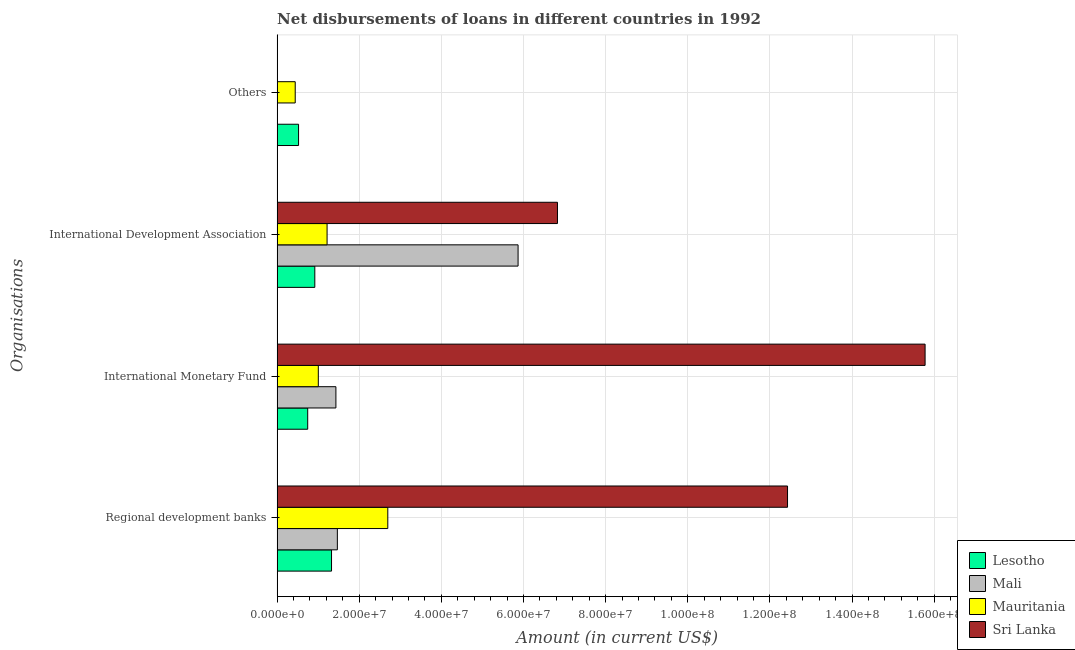How many different coloured bars are there?
Ensure brevity in your answer.  4. How many groups of bars are there?
Offer a very short reply. 4. Are the number of bars per tick equal to the number of legend labels?
Offer a very short reply. No. Are the number of bars on each tick of the Y-axis equal?
Give a very brief answer. No. How many bars are there on the 4th tick from the bottom?
Your answer should be very brief. 2. What is the label of the 3rd group of bars from the top?
Offer a very short reply. International Monetary Fund. What is the amount of loan disimbursed by regional development banks in Sri Lanka?
Ensure brevity in your answer.  1.24e+08. Across all countries, what is the maximum amount of loan disimbursed by international development association?
Your answer should be compact. 6.83e+07. Across all countries, what is the minimum amount of loan disimbursed by regional development banks?
Your answer should be compact. 1.32e+07. In which country was the amount of loan disimbursed by other organisations maximum?
Make the answer very short. Lesotho. What is the total amount of loan disimbursed by international development association in the graph?
Your response must be concise. 1.48e+08. What is the difference between the amount of loan disimbursed by international development association in Sri Lanka and that in Mali?
Offer a very short reply. 9.59e+06. What is the difference between the amount of loan disimbursed by international monetary fund in Mauritania and the amount of loan disimbursed by regional development banks in Sri Lanka?
Provide a short and direct response. -1.14e+08. What is the average amount of loan disimbursed by regional development banks per country?
Keep it short and to the point. 4.48e+07. What is the difference between the amount of loan disimbursed by international monetary fund and amount of loan disimbursed by international development association in Mali?
Keep it short and to the point. -4.44e+07. In how many countries, is the amount of loan disimbursed by other organisations greater than 24000000 US$?
Keep it short and to the point. 0. What is the ratio of the amount of loan disimbursed by international development association in Sri Lanka to that in Mali?
Provide a short and direct response. 1.16. What is the difference between the highest and the second highest amount of loan disimbursed by international monetary fund?
Offer a terse response. 1.43e+08. What is the difference between the highest and the lowest amount of loan disimbursed by international development association?
Your answer should be compact. 5.91e+07. In how many countries, is the amount of loan disimbursed by international development association greater than the average amount of loan disimbursed by international development association taken over all countries?
Your response must be concise. 2. Is it the case that in every country, the sum of the amount of loan disimbursed by other organisations and amount of loan disimbursed by international monetary fund is greater than the sum of amount of loan disimbursed by regional development banks and amount of loan disimbursed by international development association?
Give a very brief answer. No. Is it the case that in every country, the sum of the amount of loan disimbursed by regional development banks and amount of loan disimbursed by international monetary fund is greater than the amount of loan disimbursed by international development association?
Ensure brevity in your answer.  No. How many bars are there?
Provide a short and direct response. 14. Are all the bars in the graph horizontal?
Your answer should be compact. Yes. Are the values on the major ticks of X-axis written in scientific E-notation?
Your answer should be very brief. Yes. Where does the legend appear in the graph?
Your answer should be very brief. Bottom right. How many legend labels are there?
Ensure brevity in your answer.  4. What is the title of the graph?
Offer a terse response. Net disbursements of loans in different countries in 1992. What is the label or title of the Y-axis?
Make the answer very short. Organisations. What is the Amount (in current US$) in Lesotho in Regional development banks?
Your answer should be compact. 1.32e+07. What is the Amount (in current US$) in Mali in Regional development banks?
Offer a very short reply. 1.47e+07. What is the Amount (in current US$) of Mauritania in Regional development banks?
Your answer should be compact. 2.69e+07. What is the Amount (in current US$) in Sri Lanka in Regional development banks?
Offer a very short reply. 1.24e+08. What is the Amount (in current US$) of Lesotho in International Monetary Fund?
Keep it short and to the point. 7.44e+06. What is the Amount (in current US$) of Mali in International Monetary Fund?
Your response must be concise. 1.43e+07. What is the Amount (in current US$) of Mauritania in International Monetary Fund?
Make the answer very short. 1.00e+07. What is the Amount (in current US$) of Sri Lanka in International Monetary Fund?
Provide a succinct answer. 1.58e+08. What is the Amount (in current US$) of Lesotho in International Development Association?
Ensure brevity in your answer.  9.17e+06. What is the Amount (in current US$) in Mali in International Development Association?
Give a very brief answer. 5.87e+07. What is the Amount (in current US$) of Mauritania in International Development Association?
Ensure brevity in your answer.  1.22e+07. What is the Amount (in current US$) of Sri Lanka in International Development Association?
Keep it short and to the point. 6.83e+07. What is the Amount (in current US$) in Lesotho in Others?
Provide a succinct answer. 5.22e+06. What is the Amount (in current US$) in Mali in Others?
Offer a very short reply. 0. What is the Amount (in current US$) in Mauritania in Others?
Your answer should be compact. 4.40e+06. What is the Amount (in current US$) of Sri Lanka in Others?
Your answer should be compact. 0. Across all Organisations, what is the maximum Amount (in current US$) of Lesotho?
Give a very brief answer. 1.32e+07. Across all Organisations, what is the maximum Amount (in current US$) of Mali?
Make the answer very short. 5.87e+07. Across all Organisations, what is the maximum Amount (in current US$) in Mauritania?
Offer a terse response. 2.69e+07. Across all Organisations, what is the maximum Amount (in current US$) in Sri Lanka?
Your answer should be compact. 1.58e+08. Across all Organisations, what is the minimum Amount (in current US$) of Lesotho?
Keep it short and to the point. 5.22e+06. Across all Organisations, what is the minimum Amount (in current US$) in Mauritania?
Provide a succinct answer. 4.40e+06. What is the total Amount (in current US$) of Lesotho in the graph?
Offer a very short reply. 3.51e+07. What is the total Amount (in current US$) in Mali in the graph?
Your answer should be very brief. 8.76e+07. What is the total Amount (in current US$) in Mauritania in the graph?
Your answer should be compact. 5.35e+07. What is the total Amount (in current US$) of Sri Lanka in the graph?
Your response must be concise. 3.50e+08. What is the difference between the Amount (in current US$) in Lesotho in Regional development banks and that in International Monetary Fund?
Offer a very short reply. 5.80e+06. What is the difference between the Amount (in current US$) of Mali in Regional development banks and that in International Monetary Fund?
Offer a terse response. 3.55e+05. What is the difference between the Amount (in current US$) in Mauritania in Regional development banks and that in International Monetary Fund?
Your answer should be very brief. 1.69e+07. What is the difference between the Amount (in current US$) of Sri Lanka in Regional development banks and that in International Monetary Fund?
Your response must be concise. -3.35e+07. What is the difference between the Amount (in current US$) in Lesotho in Regional development banks and that in International Development Association?
Your answer should be very brief. 4.07e+06. What is the difference between the Amount (in current US$) in Mali in Regional development banks and that in International Development Association?
Provide a succinct answer. -4.40e+07. What is the difference between the Amount (in current US$) in Mauritania in Regional development banks and that in International Development Association?
Offer a very short reply. 1.48e+07. What is the difference between the Amount (in current US$) in Sri Lanka in Regional development banks and that in International Development Association?
Ensure brevity in your answer.  5.60e+07. What is the difference between the Amount (in current US$) in Lesotho in Regional development banks and that in Others?
Keep it short and to the point. 8.03e+06. What is the difference between the Amount (in current US$) in Mauritania in Regional development banks and that in Others?
Your answer should be very brief. 2.25e+07. What is the difference between the Amount (in current US$) of Lesotho in International Monetary Fund and that in International Development Association?
Provide a short and direct response. -1.73e+06. What is the difference between the Amount (in current US$) in Mali in International Monetary Fund and that in International Development Association?
Offer a very short reply. -4.44e+07. What is the difference between the Amount (in current US$) of Mauritania in International Monetary Fund and that in International Development Association?
Offer a terse response. -2.14e+06. What is the difference between the Amount (in current US$) of Sri Lanka in International Monetary Fund and that in International Development Association?
Provide a succinct answer. 8.95e+07. What is the difference between the Amount (in current US$) of Lesotho in International Monetary Fund and that in Others?
Ensure brevity in your answer.  2.23e+06. What is the difference between the Amount (in current US$) in Mauritania in International Monetary Fund and that in Others?
Your answer should be compact. 5.62e+06. What is the difference between the Amount (in current US$) in Lesotho in International Development Association and that in Others?
Offer a terse response. 3.96e+06. What is the difference between the Amount (in current US$) of Mauritania in International Development Association and that in Others?
Make the answer very short. 7.76e+06. What is the difference between the Amount (in current US$) of Lesotho in Regional development banks and the Amount (in current US$) of Mali in International Monetary Fund?
Your answer should be compact. -1.07e+06. What is the difference between the Amount (in current US$) of Lesotho in Regional development banks and the Amount (in current US$) of Mauritania in International Monetary Fund?
Provide a succinct answer. 3.22e+06. What is the difference between the Amount (in current US$) of Lesotho in Regional development banks and the Amount (in current US$) of Sri Lanka in International Monetary Fund?
Your answer should be very brief. -1.45e+08. What is the difference between the Amount (in current US$) in Mali in Regional development banks and the Amount (in current US$) in Mauritania in International Monetary Fund?
Your response must be concise. 4.64e+06. What is the difference between the Amount (in current US$) in Mali in Regional development banks and the Amount (in current US$) in Sri Lanka in International Monetary Fund?
Offer a very short reply. -1.43e+08. What is the difference between the Amount (in current US$) in Mauritania in Regional development banks and the Amount (in current US$) in Sri Lanka in International Monetary Fund?
Your answer should be compact. -1.31e+08. What is the difference between the Amount (in current US$) in Lesotho in Regional development banks and the Amount (in current US$) in Mali in International Development Association?
Your response must be concise. -4.54e+07. What is the difference between the Amount (in current US$) of Lesotho in Regional development banks and the Amount (in current US$) of Mauritania in International Development Association?
Your response must be concise. 1.08e+06. What is the difference between the Amount (in current US$) in Lesotho in Regional development banks and the Amount (in current US$) in Sri Lanka in International Development Association?
Keep it short and to the point. -5.50e+07. What is the difference between the Amount (in current US$) in Mali in Regional development banks and the Amount (in current US$) in Mauritania in International Development Association?
Offer a very short reply. 2.50e+06. What is the difference between the Amount (in current US$) of Mali in Regional development banks and the Amount (in current US$) of Sri Lanka in International Development Association?
Provide a succinct answer. -5.36e+07. What is the difference between the Amount (in current US$) in Mauritania in Regional development banks and the Amount (in current US$) in Sri Lanka in International Development Association?
Offer a very short reply. -4.13e+07. What is the difference between the Amount (in current US$) of Lesotho in Regional development banks and the Amount (in current US$) of Mauritania in Others?
Your response must be concise. 8.84e+06. What is the difference between the Amount (in current US$) in Mali in Regional development banks and the Amount (in current US$) in Mauritania in Others?
Keep it short and to the point. 1.03e+07. What is the difference between the Amount (in current US$) in Lesotho in International Monetary Fund and the Amount (in current US$) in Mali in International Development Association?
Your answer should be very brief. -5.12e+07. What is the difference between the Amount (in current US$) of Lesotho in International Monetary Fund and the Amount (in current US$) of Mauritania in International Development Association?
Offer a terse response. -4.72e+06. What is the difference between the Amount (in current US$) of Lesotho in International Monetary Fund and the Amount (in current US$) of Sri Lanka in International Development Association?
Offer a terse response. -6.08e+07. What is the difference between the Amount (in current US$) of Mali in International Monetary Fund and the Amount (in current US$) of Mauritania in International Development Association?
Your response must be concise. 2.15e+06. What is the difference between the Amount (in current US$) in Mali in International Monetary Fund and the Amount (in current US$) in Sri Lanka in International Development Association?
Your response must be concise. -5.39e+07. What is the difference between the Amount (in current US$) of Mauritania in International Monetary Fund and the Amount (in current US$) of Sri Lanka in International Development Association?
Provide a succinct answer. -5.82e+07. What is the difference between the Amount (in current US$) in Lesotho in International Monetary Fund and the Amount (in current US$) in Mauritania in Others?
Your answer should be compact. 3.04e+06. What is the difference between the Amount (in current US$) of Mali in International Monetary Fund and the Amount (in current US$) of Mauritania in Others?
Ensure brevity in your answer.  9.91e+06. What is the difference between the Amount (in current US$) in Lesotho in International Development Association and the Amount (in current US$) in Mauritania in Others?
Your answer should be compact. 4.77e+06. What is the difference between the Amount (in current US$) in Mali in International Development Association and the Amount (in current US$) in Mauritania in Others?
Give a very brief answer. 5.43e+07. What is the average Amount (in current US$) of Lesotho per Organisations?
Keep it short and to the point. 8.77e+06. What is the average Amount (in current US$) in Mali per Organisations?
Your answer should be very brief. 2.19e+07. What is the average Amount (in current US$) of Mauritania per Organisations?
Provide a short and direct response. 1.34e+07. What is the average Amount (in current US$) in Sri Lanka per Organisations?
Offer a very short reply. 8.76e+07. What is the difference between the Amount (in current US$) in Lesotho and Amount (in current US$) in Mali in Regional development banks?
Ensure brevity in your answer.  -1.42e+06. What is the difference between the Amount (in current US$) in Lesotho and Amount (in current US$) in Mauritania in Regional development banks?
Offer a terse response. -1.37e+07. What is the difference between the Amount (in current US$) in Lesotho and Amount (in current US$) in Sri Lanka in Regional development banks?
Keep it short and to the point. -1.11e+08. What is the difference between the Amount (in current US$) of Mali and Amount (in current US$) of Mauritania in Regional development banks?
Give a very brief answer. -1.23e+07. What is the difference between the Amount (in current US$) of Mali and Amount (in current US$) of Sri Lanka in Regional development banks?
Offer a very short reply. -1.10e+08. What is the difference between the Amount (in current US$) in Mauritania and Amount (in current US$) in Sri Lanka in Regional development banks?
Ensure brevity in your answer.  -9.73e+07. What is the difference between the Amount (in current US$) of Lesotho and Amount (in current US$) of Mali in International Monetary Fund?
Provide a short and direct response. -6.87e+06. What is the difference between the Amount (in current US$) of Lesotho and Amount (in current US$) of Mauritania in International Monetary Fund?
Ensure brevity in your answer.  -2.58e+06. What is the difference between the Amount (in current US$) in Lesotho and Amount (in current US$) in Sri Lanka in International Monetary Fund?
Your answer should be compact. -1.50e+08. What is the difference between the Amount (in current US$) in Mali and Amount (in current US$) in Mauritania in International Monetary Fund?
Your answer should be compact. 4.28e+06. What is the difference between the Amount (in current US$) of Mali and Amount (in current US$) of Sri Lanka in International Monetary Fund?
Make the answer very short. -1.43e+08. What is the difference between the Amount (in current US$) in Mauritania and Amount (in current US$) in Sri Lanka in International Monetary Fund?
Ensure brevity in your answer.  -1.48e+08. What is the difference between the Amount (in current US$) in Lesotho and Amount (in current US$) in Mali in International Development Association?
Give a very brief answer. -4.95e+07. What is the difference between the Amount (in current US$) in Lesotho and Amount (in current US$) in Mauritania in International Development Association?
Your answer should be very brief. -2.99e+06. What is the difference between the Amount (in current US$) of Lesotho and Amount (in current US$) of Sri Lanka in International Development Association?
Offer a terse response. -5.91e+07. What is the difference between the Amount (in current US$) in Mali and Amount (in current US$) in Mauritania in International Development Association?
Provide a succinct answer. 4.65e+07. What is the difference between the Amount (in current US$) in Mali and Amount (in current US$) in Sri Lanka in International Development Association?
Keep it short and to the point. -9.59e+06. What is the difference between the Amount (in current US$) in Mauritania and Amount (in current US$) in Sri Lanka in International Development Association?
Your answer should be very brief. -5.61e+07. What is the difference between the Amount (in current US$) of Lesotho and Amount (in current US$) of Mauritania in Others?
Keep it short and to the point. 8.13e+05. What is the ratio of the Amount (in current US$) in Lesotho in Regional development banks to that in International Monetary Fund?
Your answer should be compact. 1.78. What is the ratio of the Amount (in current US$) of Mali in Regional development banks to that in International Monetary Fund?
Ensure brevity in your answer.  1.02. What is the ratio of the Amount (in current US$) in Mauritania in Regional development banks to that in International Monetary Fund?
Keep it short and to the point. 2.69. What is the ratio of the Amount (in current US$) in Sri Lanka in Regional development banks to that in International Monetary Fund?
Your answer should be compact. 0.79. What is the ratio of the Amount (in current US$) in Lesotho in Regional development banks to that in International Development Association?
Make the answer very short. 1.44. What is the ratio of the Amount (in current US$) in Mauritania in Regional development banks to that in International Development Association?
Make the answer very short. 2.22. What is the ratio of the Amount (in current US$) of Sri Lanka in Regional development banks to that in International Development Association?
Your answer should be compact. 1.82. What is the ratio of the Amount (in current US$) of Lesotho in Regional development banks to that in Others?
Your answer should be compact. 2.54. What is the ratio of the Amount (in current US$) of Mauritania in Regional development banks to that in Others?
Your answer should be compact. 6.12. What is the ratio of the Amount (in current US$) of Lesotho in International Monetary Fund to that in International Development Association?
Offer a very short reply. 0.81. What is the ratio of the Amount (in current US$) of Mali in International Monetary Fund to that in International Development Association?
Your answer should be very brief. 0.24. What is the ratio of the Amount (in current US$) in Mauritania in International Monetary Fund to that in International Development Association?
Offer a very short reply. 0.82. What is the ratio of the Amount (in current US$) of Sri Lanka in International Monetary Fund to that in International Development Association?
Make the answer very short. 2.31. What is the ratio of the Amount (in current US$) of Lesotho in International Monetary Fund to that in Others?
Provide a succinct answer. 1.43. What is the ratio of the Amount (in current US$) of Mauritania in International Monetary Fund to that in Others?
Your response must be concise. 2.28. What is the ratio of the Amount (in current US$) in Lesotho in International Development Association to that in Others?
Provide a short and direct response. 1.76. What is the ratio of the Amount (in current US$) of Mauritania in International Development Association to that in Others?
Your answer should be compact. 2.76. What is the difference between the highest and the second highest Amount (in current US$) of Lesotho?
Make the answer very short. 4.07e+06. What is the difference between the highest and the second highest Amount (in current US$) of Mali?
Offer a very short reply. 4.40e+07. What is the difference between the highest and the second highest Amount (in current US$) in Mauritania?
Your answer should be compact. 1.48e+07. What is the difference between the highest and the second highest Amount (in current US$) of Sri Lanka?
Your answer should be very brief. 3.35e+07. What is the difference between the highest and the lowest Amount (in current US$) in Lesotho?
Make the answer very short. 8.03e+06. What is the difference between the highest and the lowest Amount (in current US$) of Mali?
Ensure brevity in your answer.  5.87e+07. What is the difference between the highest and the lowest Amount (in current US$) in Mauritania?
Your answer should be compact. 2.25e+07. What is the difference between the highest and the lowest Amount (in current US$) in Sri Lanka?
Make the answer very short. 1.58e+08. 